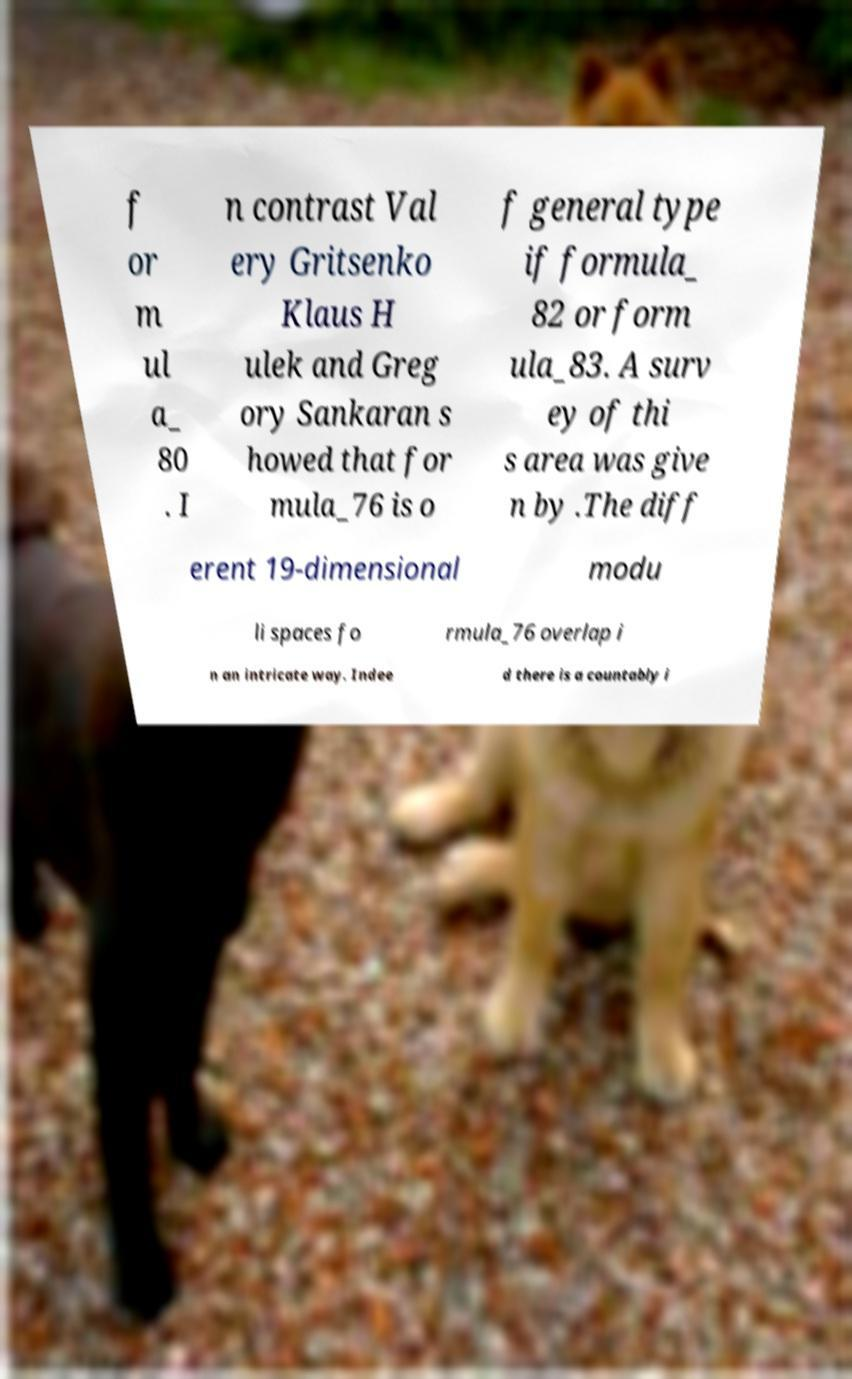For documentation purposes, I need the text within this image transcribed. Could you provide that? f or m ul a_ 80 . I n contrast Val ery Gritsenko Klaus H ulek and Greg ory Sankaran s howed that for mula_76 is o f general type if formula_ 82 or form ula_83. A surv ey of thi s area was give n by .The diff erent 19-dimensional modu li spaces fo rmula_76 overlap i n an intricate way. Indee d there is a countably i 